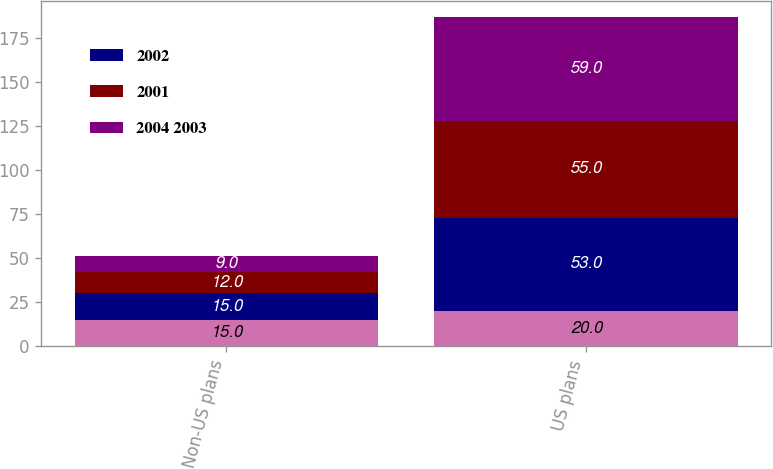Convert chart to OTSL. <chart><loc_0><loc_0><loc_500><loc_500><stacked_bar_chart><ecel><fcel>Non-US plans<fcel>US plans<nl><fcel>nan<fcel>15<fcel>20<nl><fcel>2002<fcel>15<fcel>53<nl><fcel>2001<fcel>12<fcel>55<nl><fcel>2004 2003<fcel>9<fcel>59<nl></chart> 